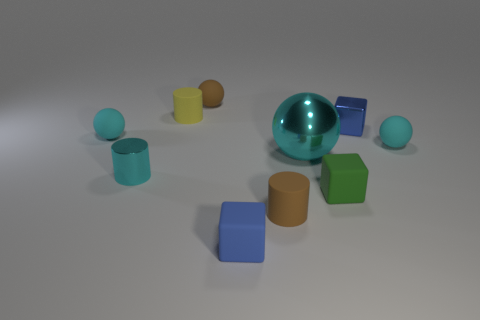Subtract all cyan balls. How many balls are left? 1 Subtract all blue cubes. How many cubes are left? 1 Subtract 0 gray cubes. How many objects are left? 10 Subtract all cubes. How many objects are left? 7 Subtract 2 spheres. How many spheres are left? 2 Subtract all purple cylinders. Subtract all brown spheres. How many cylinders are left? 3 Subtract all blue cylinders. How many cyan blocks are left? 0 Subtract all blue matte things. Subtract all small matte balls. How many objects are left? 6 Add 1 tiny shiny cubes. How many tiny shiny cubes are left? 2 Add 9 small yellow matte cylinders. How many small yellow matte cylinders exist? 10 